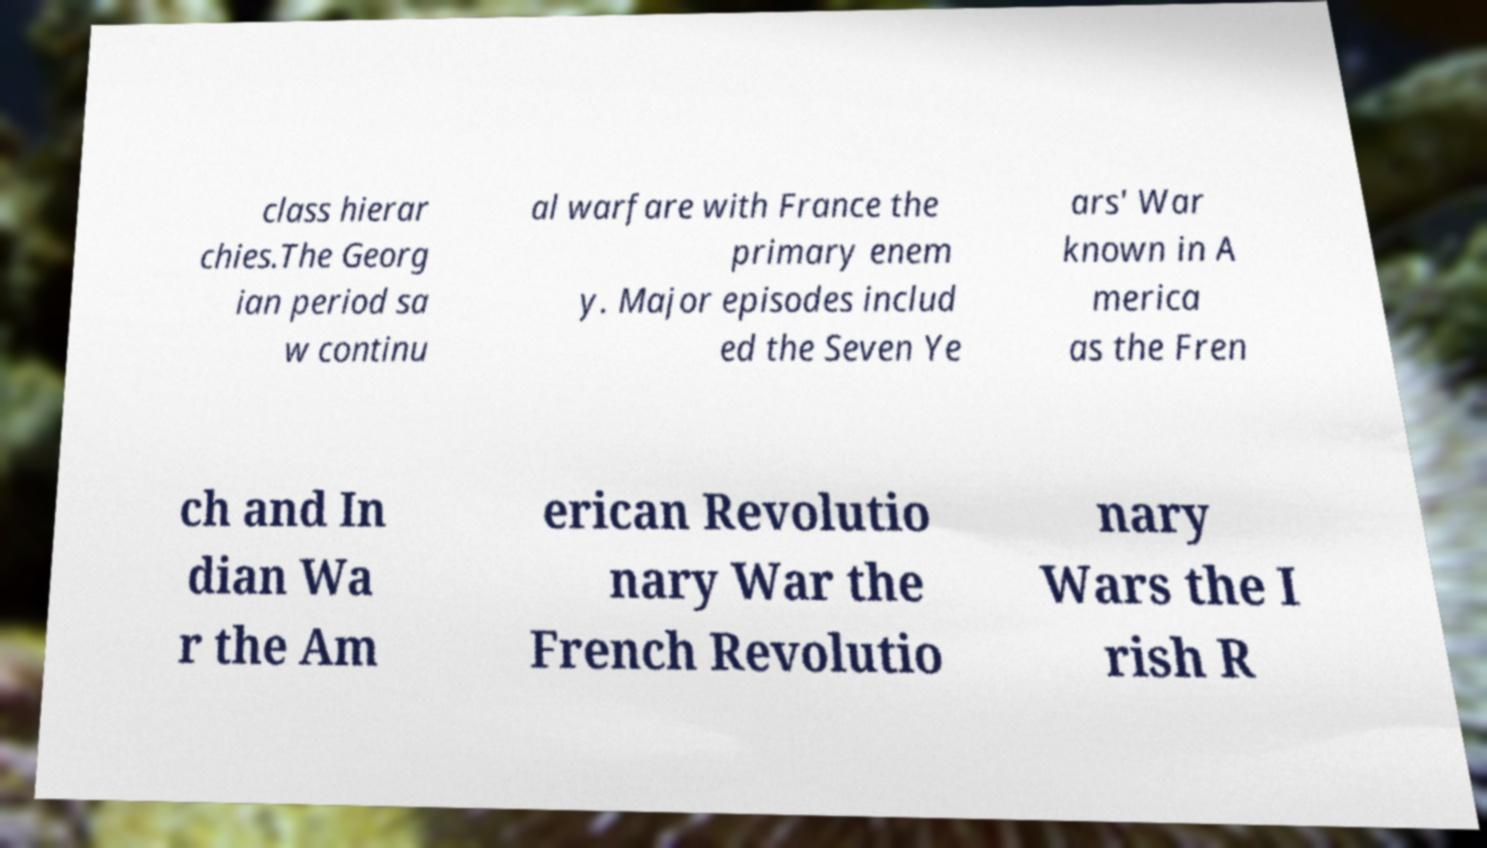Please read and relay the text visible in this image. What does it say? class hierar chies.The Georg ian period sa w continu al warfare with France the primary enem y. Major episodes includ ed the Seven Ye ars' War known in A merica as the Fren ch and In dian Wa r the Am erican Revolutio nary War the French Revolutio nary Wars the I rish R 